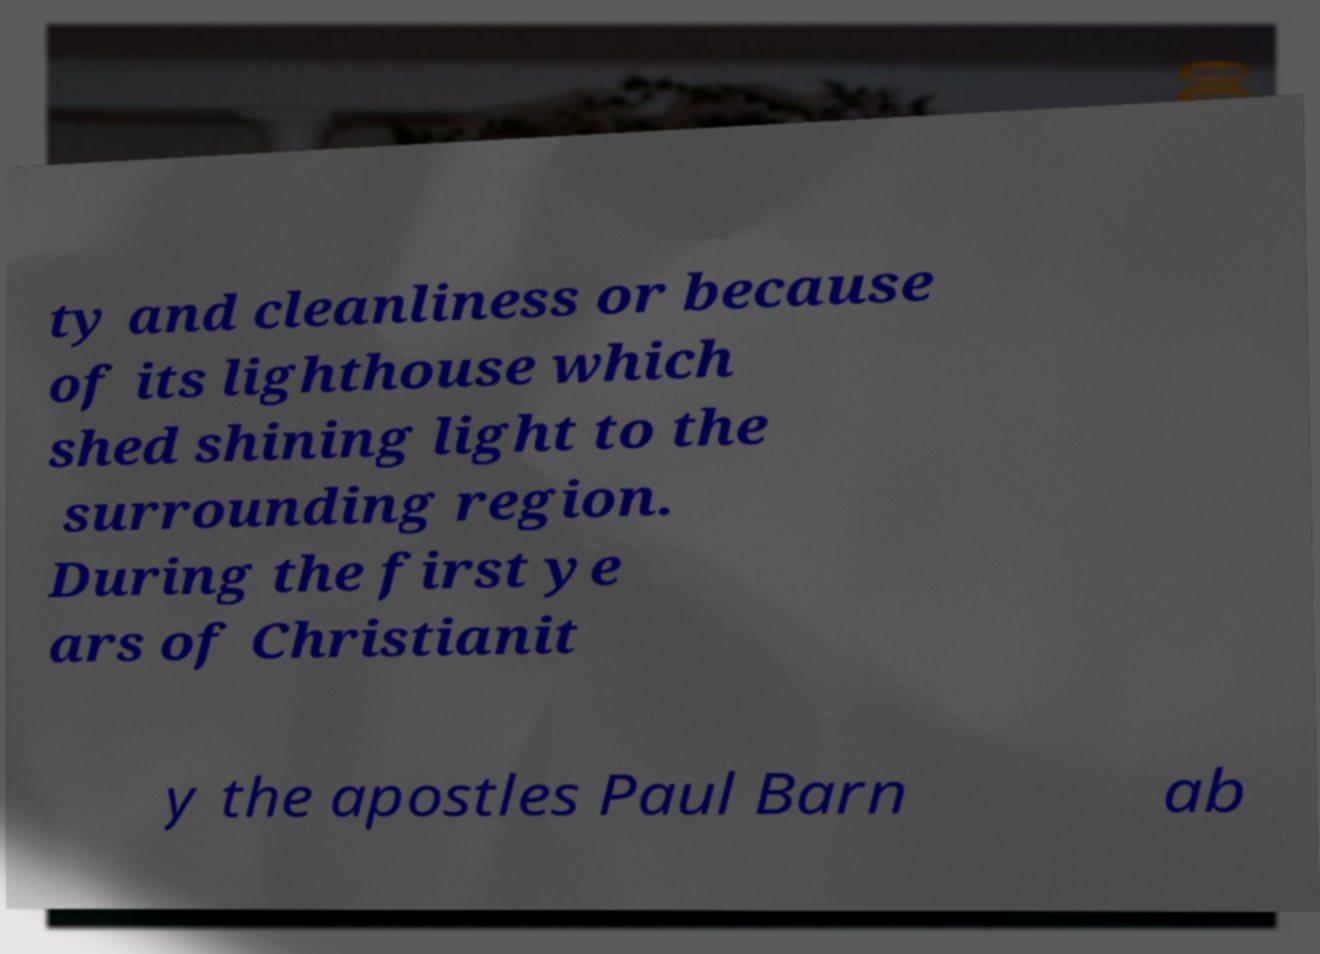There's text embedded in this image that I need extracted. Can you transcribe it verbatim? ty and cleanliness or because of its lighthouse which shed shining light to the surrounding region. During the first ye ars of Christianit y the apostles Paul Barn ab 